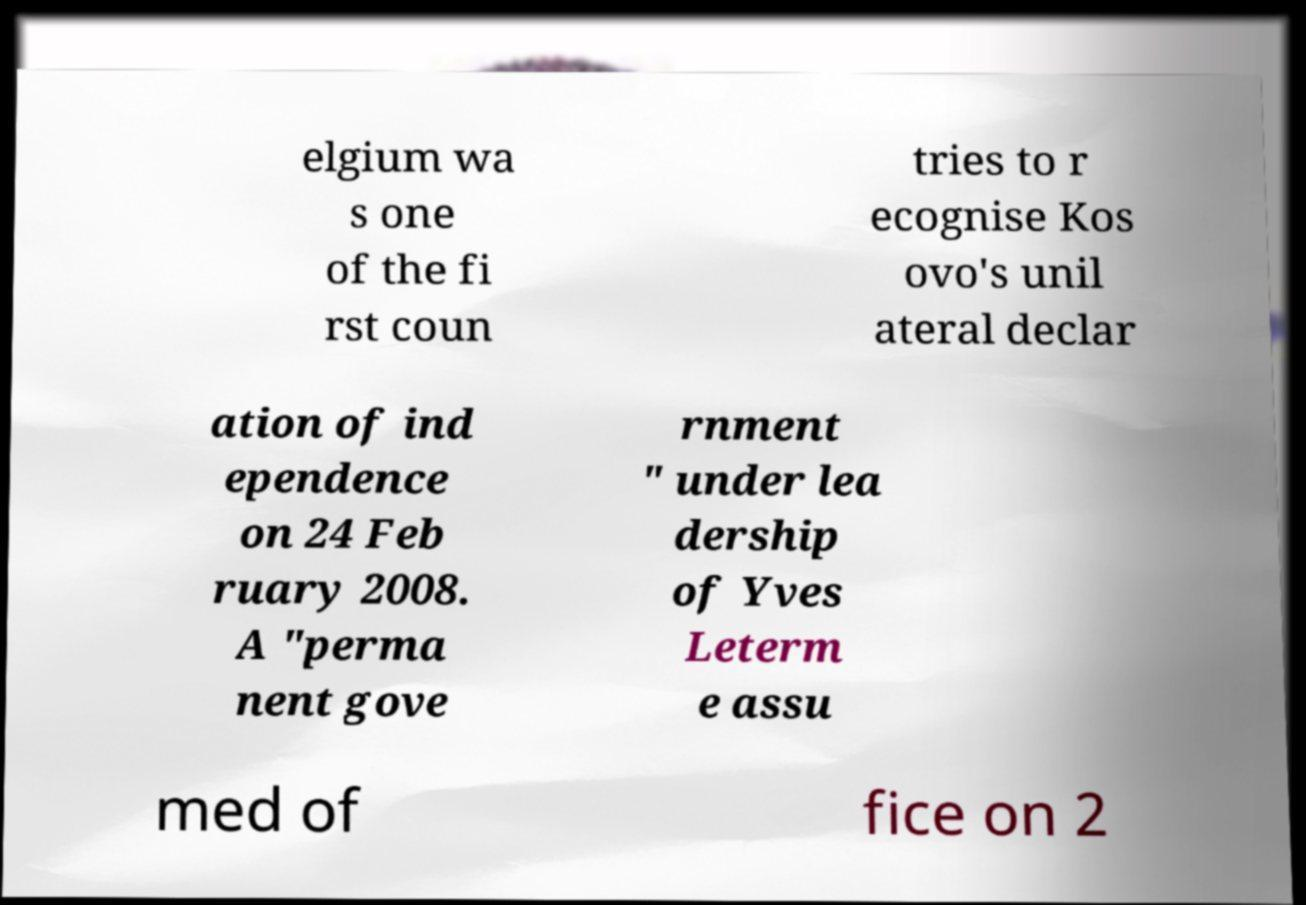I need the written content from this picture converted into text. Can you do that? elgium wa s one of the fi rst coun tries to r ecognise Kos ovo's unil ateral declar ation of ind ependence on 24 Feb ruary 2008. A "perma nent gove rnment " under lea dership of Yves Leterm e assu med of fice on 2 